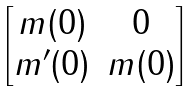Convert formula to latex. <formula><loc_0><loc_0><loc_500><loc_500>\begin{bmatrix} m ( 0 ) & 0 \\ m ^ { \prime } ( 0 ) & m ( 0 ) \end{bmatrix}</formula> 